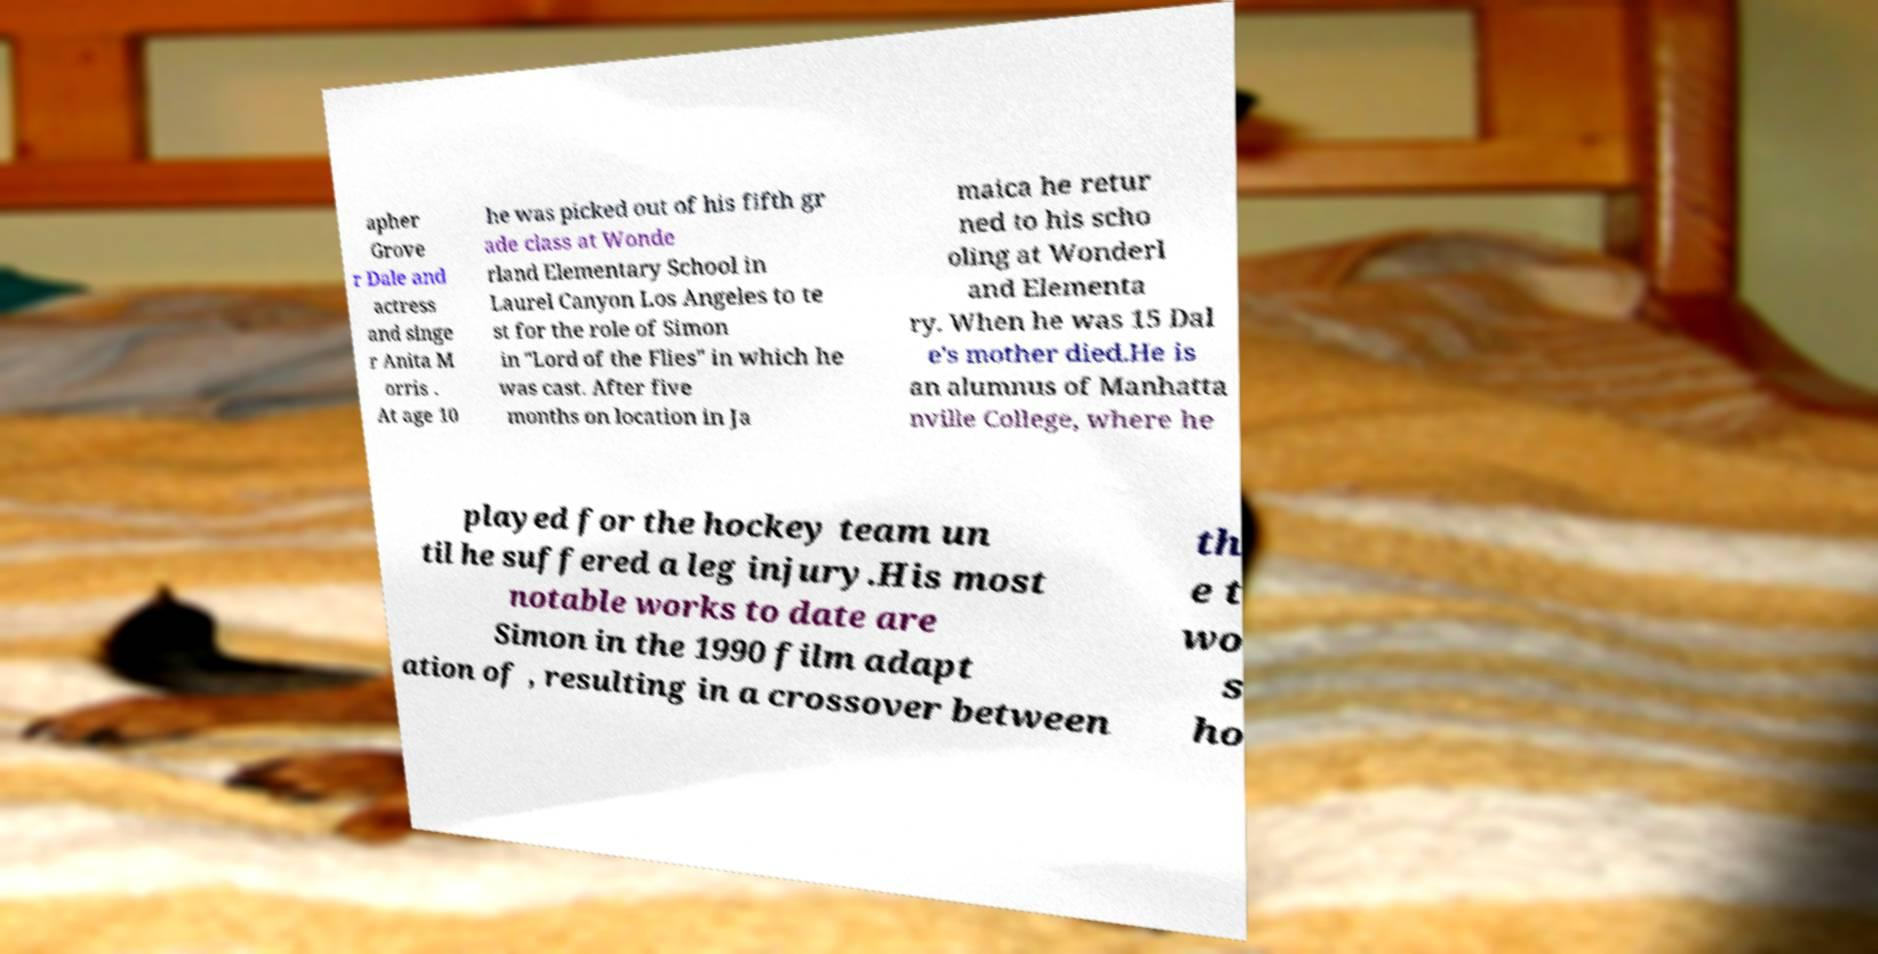Can you accurately transcribe the text from the provided image for me? apher Grove r Dale and actress and singe r Anita M orris . At age 10 he was picked out of his fifth gr ade class at Wonde rland Elementary School in Laurel Canyon Los Angeles to te st for the role of Simon in "Lord of the Flies" in which he was cast. After five months on location in Ja maica he retur ned to his scho oling at Wonderl and Elementa ry. When he was 15 Dal e's mother died.He is an alumnus of Manhatta nville College, where he played for the hockey team un til he suffered a leg injury.His most notable works to date are Simon in the 1990 film adapt ation of , resulting in a crossover between th e t wo s ho 